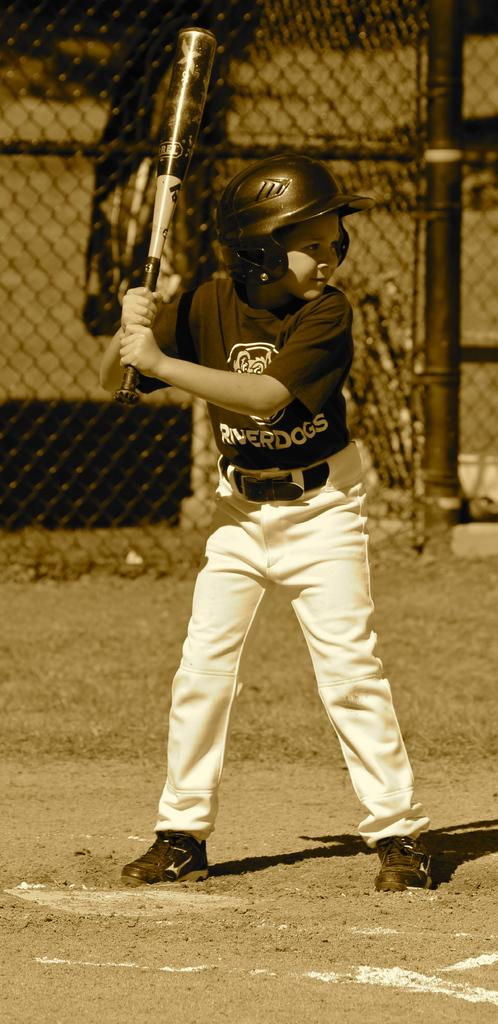What is the main subject of the image? There is a person in the image. What is the person doing in the image? The person is standing and holding a bat. What color is the person's shirt in the image? The person is wearing a black shirt. What color are the person's pants in the image? The person is wearing white pants. What can be seen in the background of the image? There is railing visible in the background of the image. What type of mitten is the person wearing on their left hand in the image? There is no mitten visible on the person's hand in the image. What calculations is the person performing with the calculator in the image? There is no calculator present in the image. 